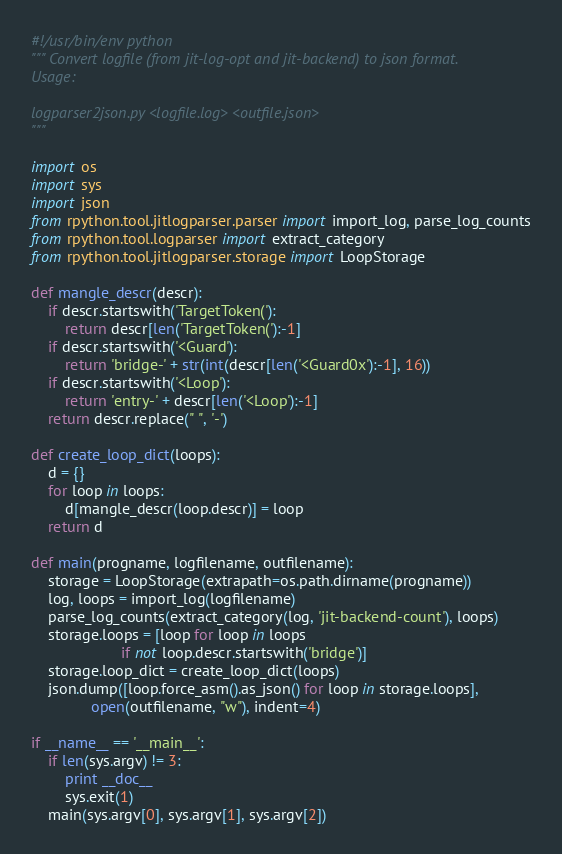Convert code to text. <code><loc_0><loc_0><loc_500><loc_500><_Python_>#!/usr/bin/env python
""" Convert logfile (from jit-log-opt and jit-backend) to json format.
Usage:

logparser2json.py <logfile.log> <outfile.json>
"""

import os
import sys
import json
from rpython.tool.jitlogparser.parser import import_log, parse_log_counts
from rpython.tool.logparser import extract_category
from rpython.tool.jitlogparser.storage import LoopStorage

def mangle_descr(descr):
    if descr.startswith('TargetToken('):
        return descr[len('TargetToken('):-1]
    if descr.startswith('<Guard'):
        return 'bridge-' + str(int(descr[len('<Guard0x'):-1], 16))
    if descr.startswith('<Loop'):
        return 'entry-' + descr[len('<Loop'):-1]
    return descr.replace(" ", '-')

def create_loop_dict(loops):
    d = {}
    for loop in loops:
        d[mangle_descr(loop.descr)] = loop
    return d

def main(progname, logfilename, outfilename):
    storage = LoopStorage(extrapath=os.path.dirname(progname))
    log, loops = import_log(logfilename)
    parse_log_counts(extract_category(log, 'jit-backend-count'), loops)
    storage.loops = [loop for loop in loops
                     if not loop.descr.startswith('bridge')]
    storage.loop_dict = create_loop_dict(loops)
    json.dump([loop.force_asm().as_json() for loop in storage.loops],
              open(outfilename, "w"), indent=4)

if __name__ == '__main__':
    if len(sys.argv) != 3:
        print __doc__
        sys.exit(1)
    main(sys.argv[0], sys.argv[1], sys.argv[2])
</code> 